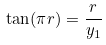Convert formula to latex. <formula><loc_0><loc_0><loc_500><loc_500>\tan ( \pi r ) = \frac { r } { y _ { 1 } }</formula> 